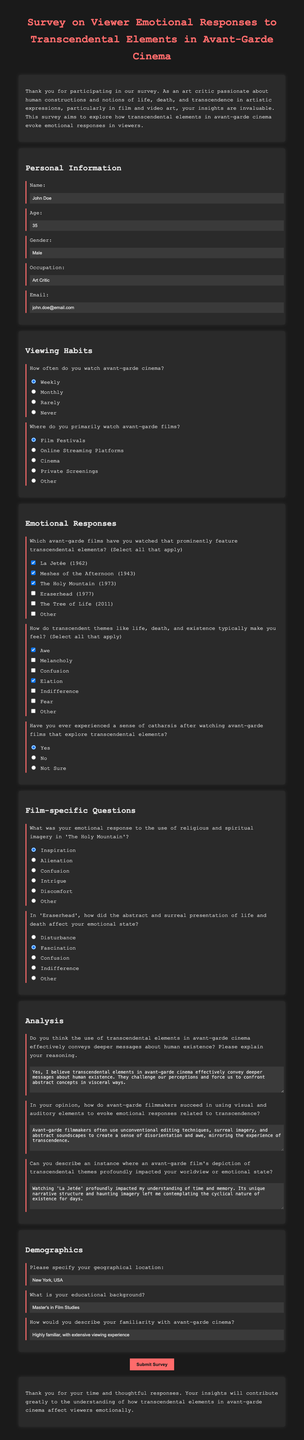What is the name of the participant? The participant's name is provided in the personal information section of the document.
Answer: John Doe How old is the participant? The age of the participant is specified in the personal information section of the document.
Answer: 35 What is the participant's email address? The participant's email address is included in the personal information section.
Answer: john.doe@email.com How often does the participant watch avant-garde cinema? The participant's viewing frequency is noted in the viewing habits section of the document.
Answer: Weekly Which film does the participant mention experiencing awe from? The participant selected feelings among the options provided in the emotional responses section of the document.
Answer: Awe What emotional response did the participant feel towards 'The Holy Mountain'? The participant's emotional response is recorded in the film-specific questions section regarding 'The Holy Mountain.'
Answer: Inspiration What geographical location is specified by the participant? The participant provides their geographical location in the demographics section of the document.
Answer: New York, USA What educational background does the participant have? The educational background of the participant is listed in the demographics section of the document.
Answer: Master's in Film Studies Does the participant believe transcendental elements convey deeper messages? The participant's opinion on this matter is indicated in the analysis section of the document.
Answer: Yes 